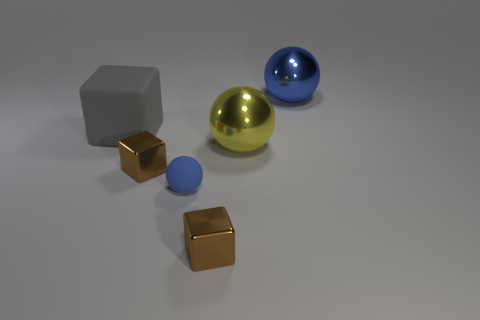Does the gray thing have the same size as the rubber object that is right of the large cube?
Your response must be concise. No. There is another shiny thing that is the same shape as the big yellow shiny object; what color is it?
Your response must be concise. Blue. There is a blue ball that is on the right side of the large yellow metal object; is its size the same as the blue rubber sphere in front of the big gray object?
Offer a terse response. No. Is the big yellow thing the same shape as the large blue metal object?
Provide a short and direct response. Yes. What number of things are either shiny objects that are in front of the large cube or gray objects?
Provide a short and direct response. 4. Are there any other gray things that have the same shape as the gray matte thing?
Ensure brevity in your answer.  No. Are there the same number of big yellow metal things that are left of the large yellow thing and big yellow spheres?
Provide a short and direct response. No. What is the shape of the shiny thing that is the same color as the rubber ball?
Make the answer very short. Sphere. How many gray matte things have the same size as the blue rubber thing?
Your answer should be compact. 0. There is a gray matte block; what number of brown objects are to the left of it?
Ensure brevity in your answer.  0. 